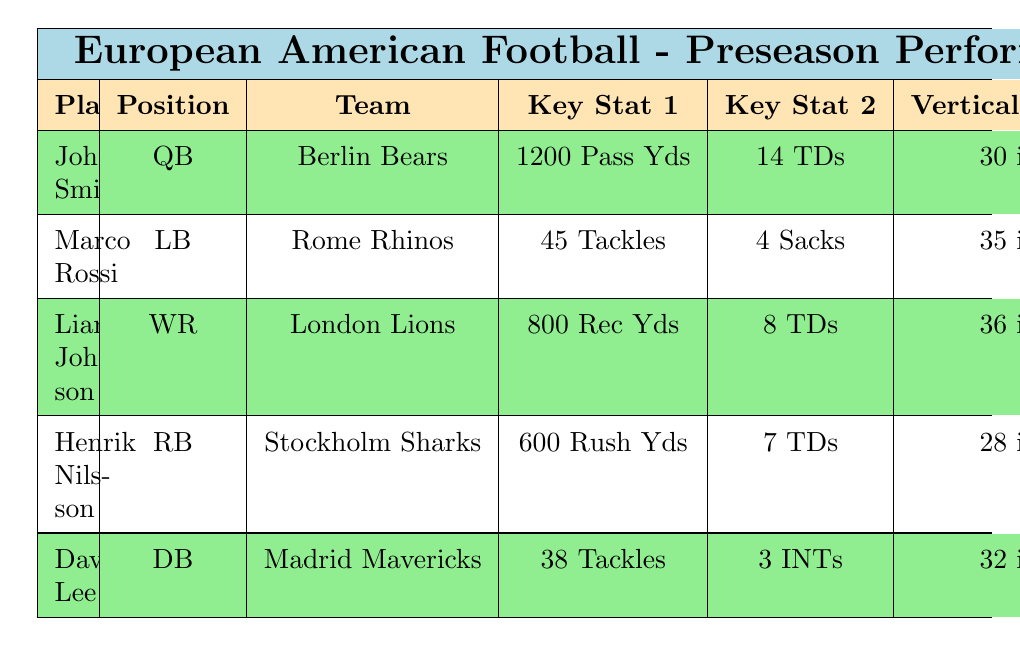What is the highest number of touchdowns scored by a player? Looking at the touchdowns column, John Smith has 14 touchdowns while Liam Johnson has 8, Henrik Nilsson has 7, Marco Rossi has only defensive stats, and David Lee has interceptions instead of touchdowns. Therefore, the highest number is 14 by John Smith.
Answer: 14 Which player had the most training sprints? By reviewing the Training Sprints column, John Smith had 30, Marco Rossi 28, Liam Johnson 32, Henrik Nilsson 30, and David Lee 29. The highest count in this column is 32 by Liam Johnson.
Answer: 32 Did any player have zero interceptions? Looking at the interceptions column: John Smith had 2, Marco Rossi had 1, Liam Johnson had none, Henrik Nilsson had none, and David Lee had 3. Since at least one player, specifically Liam Johnson and Henrik Nilsson, had zero interceptions, the answer is yes.
Answer: Yes What is the average vertical jump height of all players? The vertical jumps are 30, 35, 36, 28, and 32 inches. First, we sum these heights: 30 + 35 + 36 + 28 + 32 = 161. There are 5 players, so we divide 161 by 5 to find the average: 161 / 5 = 32.2. Thus, the average vertical jump height is 32.2 inches.
Answer: 32.2 Which player has the best agility drills score among those listed? Reviewing the Agility Drills column, John Smith has 25 seconds, Marco Rossi 22 seconds, Liam Johnson 27 seconds, Henrik Nilsson 24 seconds, and David Lee 26 seconds. Marco Rossi has the best time with 22 seconds, making him the fastest in agility drills.
Answer: 22 seconds Who had the highest receiving yards and on which team does he play? Checking the Receiving Yards column, Liam Johnson has 800 receiving yards, which is more than the rushing yards or tackles of the players listed. He plays for London Lions.
Answer: 800 yards, London Lions How many more tackles did Marco Rossi have compared to David Lee? Marco Rossi had 45 tackles and David Lee had 38. To find the difference, we subtract: 45 - 38 = 7. Marco Rossi had 7 more tackles than David Lee.
Answer: 7 Is it true that all players except Marco Rossi had at least 30 training sprints? Looking at the Training Sprints values, Marco Rossi had 28, while all others had 30 or more (John Smith 30, Liam Johnson 32, Henrik Nilsson 30, David Lee 29). Therefore, since Marco Rossi did not, the statement is false.
Answer: No Which team had a player with the highest vertical jump? By reviewing the Vertical Jump column, Liam Johnson had the highest with 36 inches, representing the London Lions.
Answer: London Lions 